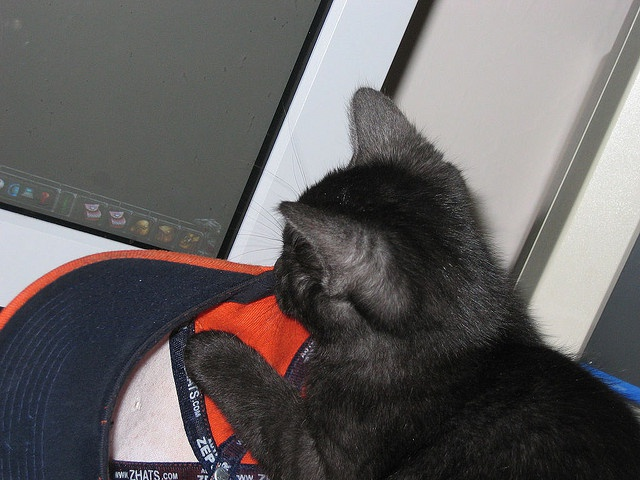Describe the objects in this image and their specific colors. I can see cat in gray and black tones, tv in gray, lightgray, black, and darkgray tones, and laptop in gray, black, lightgray, and darkgray tones in this image. 